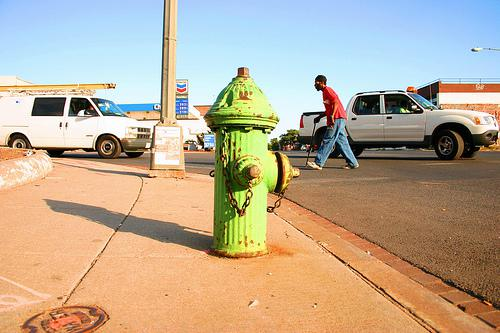Question: who is walking?
Choices:
A. The man.
B. The woman.
C. The child.
D. The Dog.
Answer with the letter. Answer: A Question: what is in front of the man?
Choices:
A. The car.
B. The hydrant.
C. The mailbox.
D. The fence.
Answer with the letter. Answer: B Question: what is on the sidewalk?
Choices:
A. Mailbox.
B. Hydrant.
C. Payphone.
D. Bicycle.
Answer with the letter. Answer: B Question: why is the man crossing the street?
Choices:
A. To get to the restaurant.
B. To reach the park.
C. To get to the other side.
D. To get to his car.
Answer with the letter. Answer: C 